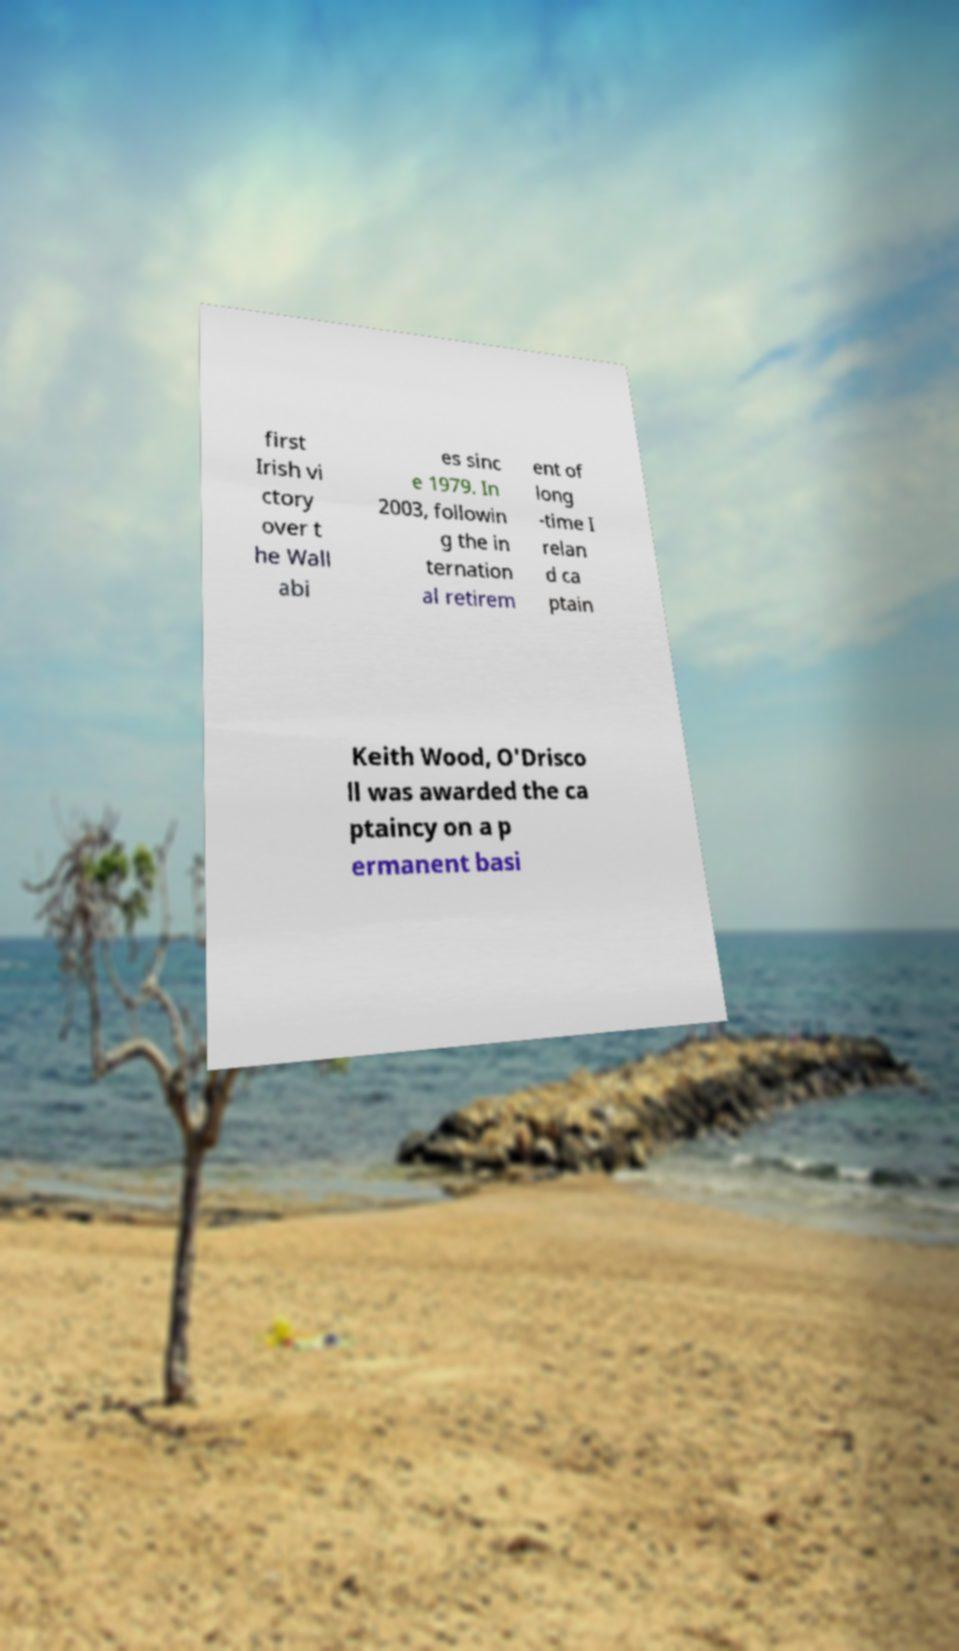Could you assist in decoding the text presented in this image and type it out clearly? first Irish vi ctory over t he Wall abi es sinc e 1979. In 2003, followin g the in ternation al retirem ent of long -time I relan d ca ptain Keith Wood, O'Drisco ll was awarded the ca ptaincy on a p ermanent basi 